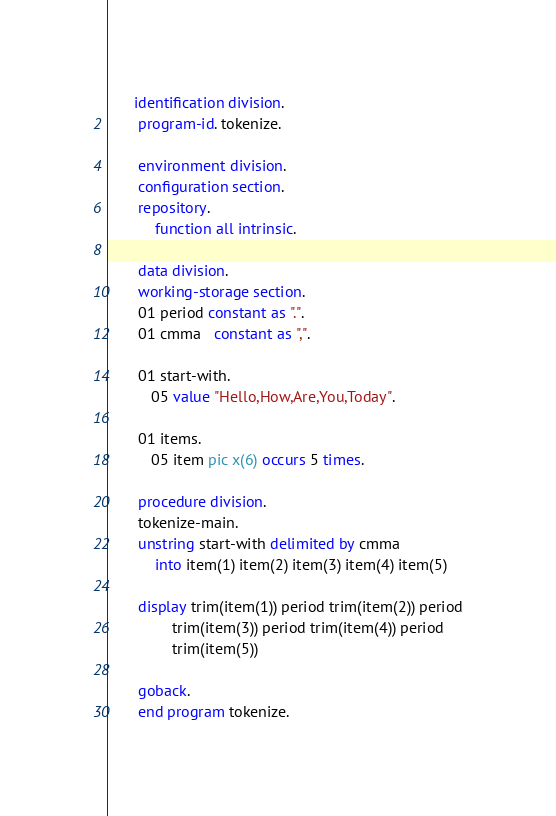Convert code to text. <code><loc_0><loc_0><loc_500><loc_500><_COBOL_>      identification division.
       program-id. tokenize.

       environment division.
       configuration section.
       repository.
           function all intrinsic.

       data division.
       working-storage section.
       01 period constant as ".".
       01 cmma   constant as ",".

       01 start-with.
          05 value "Hello,How,Are,You,Today".

       01 items.
          05 item pic x(6) occurs 5 times.

       procedure division.
       tokenize-main.
       unstring start-with delimited by cmma
           into item(1) item(2) item(3) item(4) item(5)

       display trim(item(1)) period trim(item(2)) period
               trim(item(3)) period trim(item(4)) period
               trim(item(5))

       goback.
       end program tokenize.
</code> 